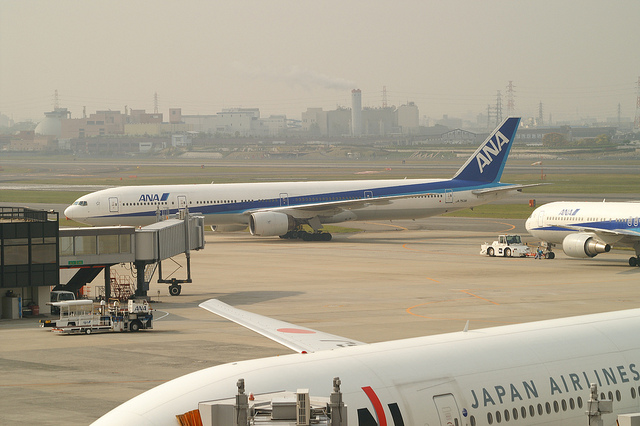What activities are depicted on the ground around the airplanes? One can see a cargo loading vehicle positioned at the cargo bay of the ANA airplane, indicating luggage or freight is being loaded or unloaded. There's also a ground support vehicle near the airplane suggesting ongoing ground operations typical for an airport. 